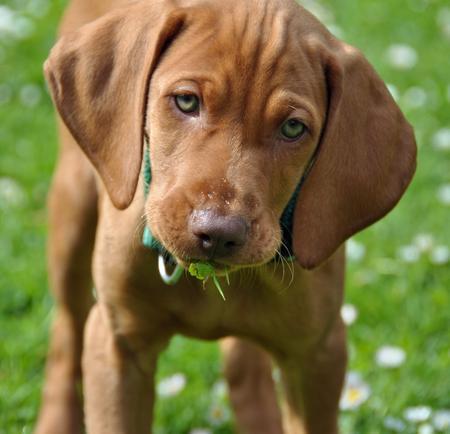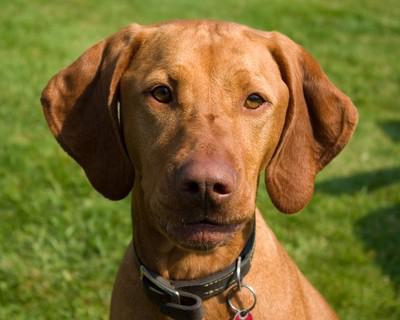The first image is the image on the left, the second image is the image on the right. For the images shown, is this caption "There are two brown dogs in collars." true? Answer yes or no. Yes. The first image is the image on the left, the second image is the image on the right. Considering the images on both sides, is "Both dogs are wearing collars." valid? Answer yes or no. Yes. 